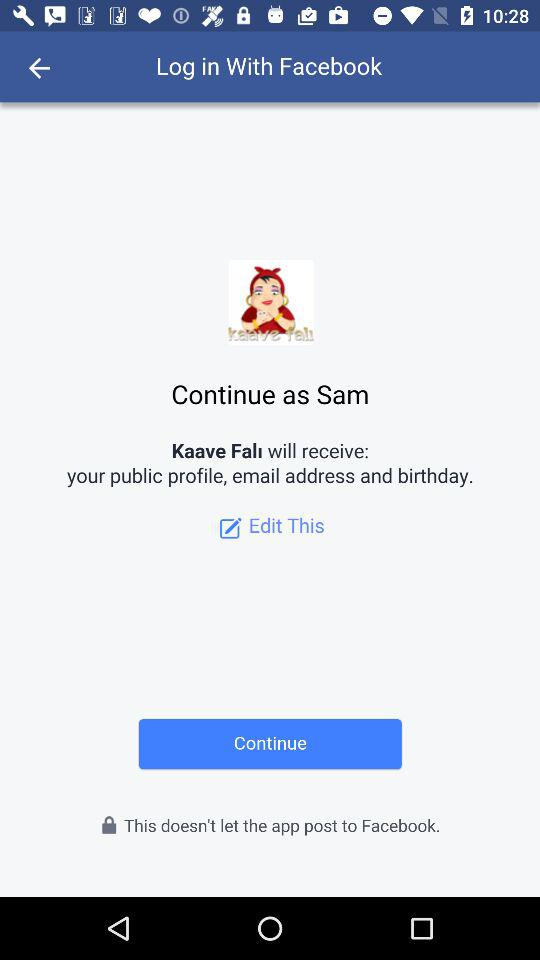Through what applications can we log in? You can log in through "Facebook". 